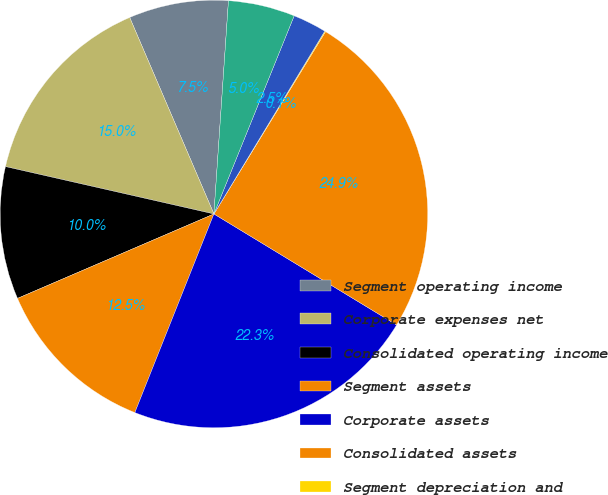<chart> <loc_0><loc_0><loc_500><loc_500><pie_chart><fcel>Segment operating income<fcel>Corporate expenses net<fcel>Consolidated operating income<fcel>Segment assets<fcel>Corporate assets<fcel>Consolidated assets<fcel>Segment depreciation and<fcel>Corporate depreciation and<fcel>Consolidated depreciation and<nl><fcel>7.53%<fcel>15.0%<fcel>10.02%<fcel>12.51%<fcel>22.34%<fcel>24.95%<fcel>0.07%<fcel>2.55%<fcel>5.04%<nl></chart> 